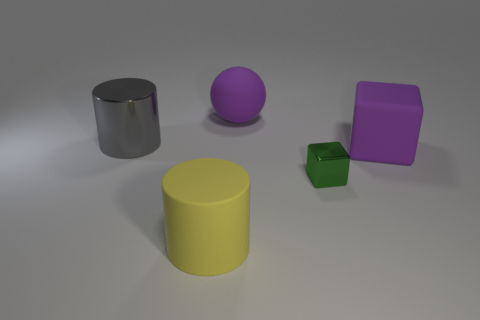Is the size of the purple rubber object on the right side of the green shiny cube the same as the metal thing behind the green shiny cube?
Ensure brevity in your answer.  Yes. Is the number of gray metal objects that are in front of the big cube greater than the number of big yellow objects that are right of the small block?
Make the answer very short. No. Are there any big purple blocks made of the same material as the ball?
Make the answer very short. Yes. Is the color of the large cube the same as the ball?
Provide a short and direct response. Yes. There is a large thing that is both behind the green cube and in front of the big gray cylinder; what is its material?
Provide a succinct answer. Rubber. What color is the rubber cube?
Offer a terse response. Purple. How many yellow rubber objects have the same shape as the gray metallic object?
Offer a very short reply. 1. Does the large purple object on the right side of the tiny green object have the same material as the large thing behind the large gray object?
Offer a very short reply. Yes. There is a cylinder in front of the rubber thing to the right of the big purple rubber ball; what is its size?
Your response must be concise. Large. Are there any other things that have the same size as the green metal cube?
Offer a very short reply. No. 